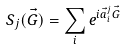<formula> <loc_0><loc_0><loc_500><loc_500>S _ { j } ( \vec { G } ) = \sum _ { i } e ^ { i \vec { a } _ { i } ^ { j } \vec { G } }</formula> 